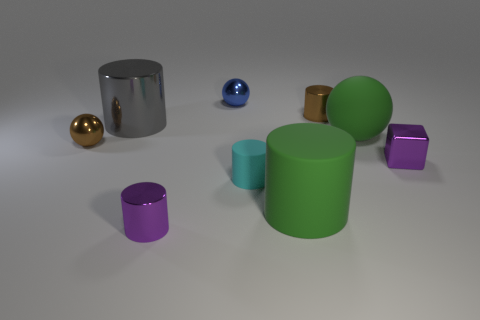There is a tiny object that is the same color as the block; what material is it?
Keep it short and to the point. Metal. Are there any rubber balls of the same size as the cyan matte cylinder?
Your answer should be compact. No. How big is the sphere that is left of the purple cylinder?
Your answer should be very brief. Small. Is there a small purple object in front of the tiny metal object that is right of the brown cylinder?
Offer a very short reply. Yes. How many other things are the same shape as the large gray metal object?
Your answer should be very brief. 4. Is the gray object the same shape as the tiny blue thing?
Offer a terse response. No. The large object that is behind the purple metallic block and left of the big ball is what color?
Make the answer very short. Gray. There is a object that is the same color as the metal cube; what is its size?
Your answer should be very brief. Small. How many tiny objects are either purple spheres or gray shiny things?
Provide a short and direct response. 0. Are there any other things that have the same color as the metallic cube?
Offer a terse response. Yes. 